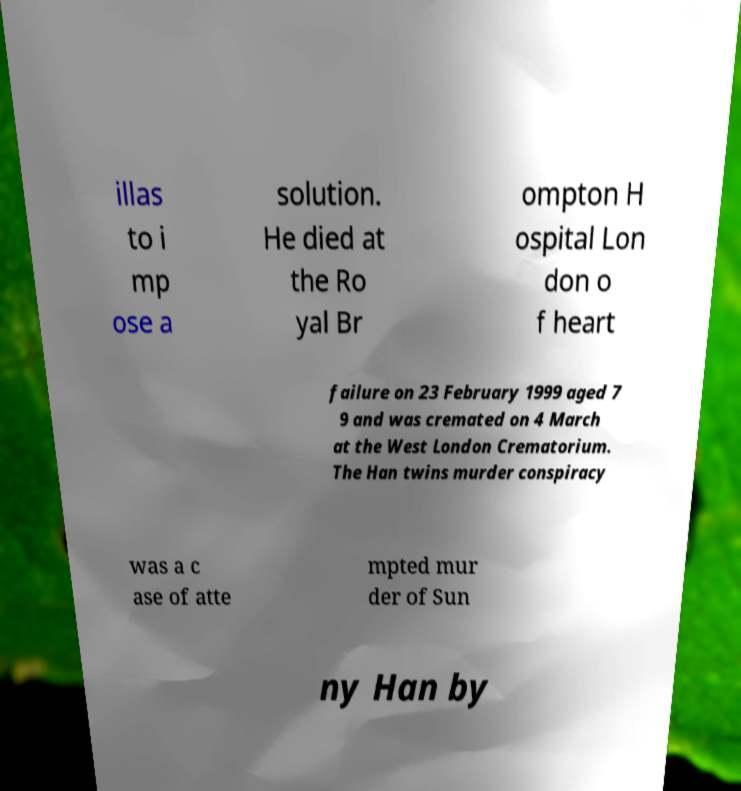Please read and relay the text visible in this image. What does it say? illas to i mp ose a solution. He died at the Ro yal Br ompton H ospital Lon don o f heart failure on 23 February 1999 aged 7 9 and was cremated on 4 March at the West London Crematorium. The Han twins murder conspiracy was a c ase of atte mpted mur der of Sun ny Han by 